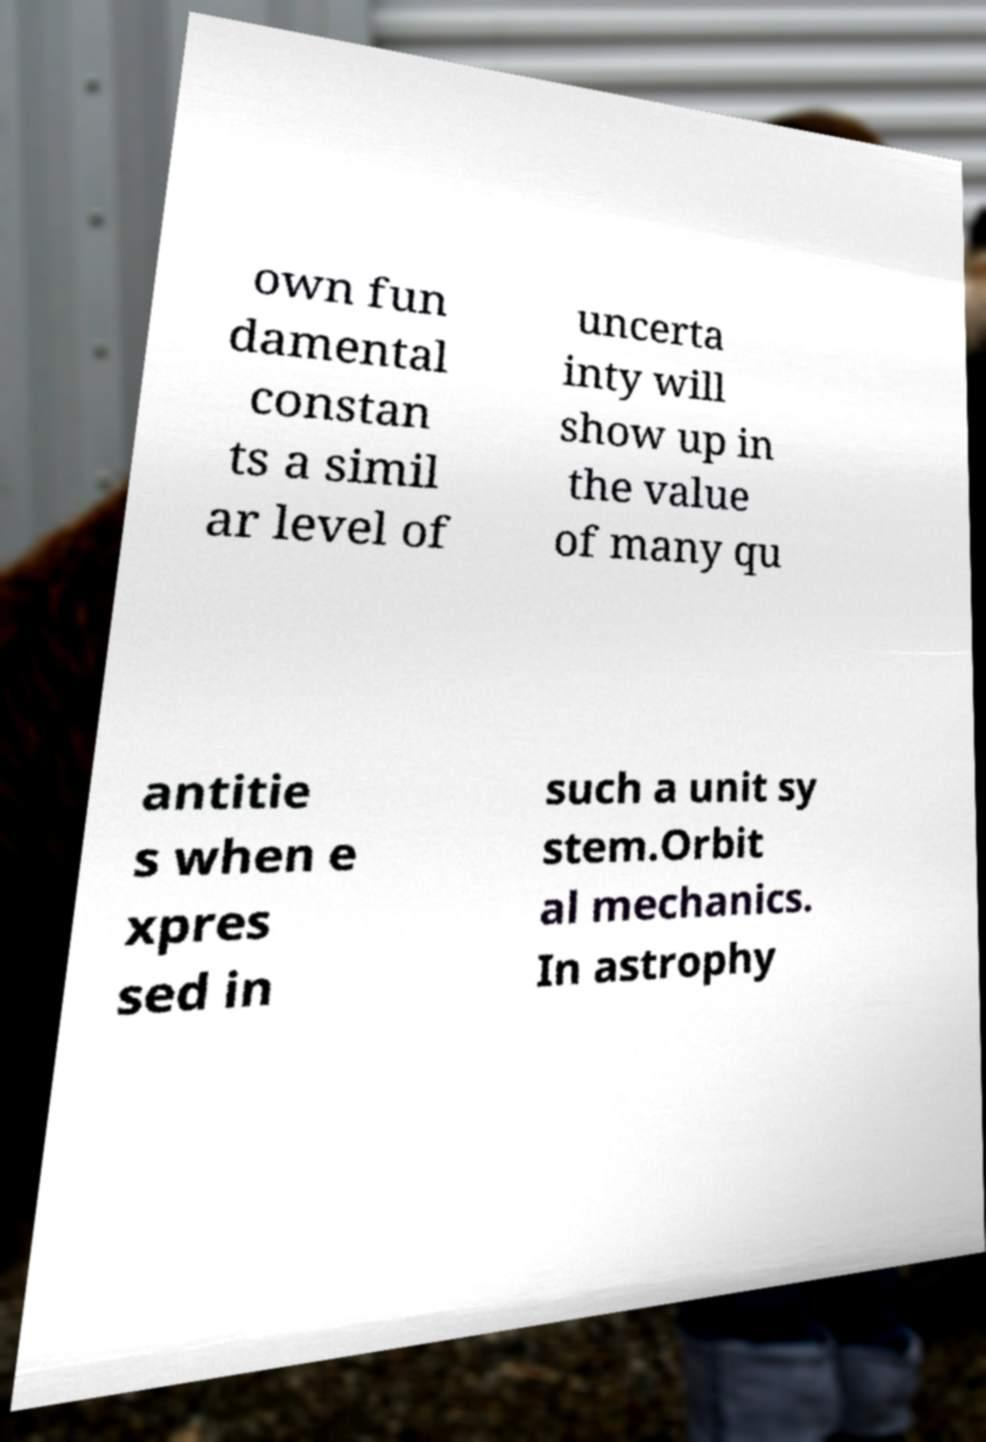Could you assist in decoding the text presented in this image and type it out clearly? own fun damental constan ts a simil ar level of uncerta inty will show up in the value of many qu antitie s when e xpres sed in such a unit sy stem.Orbit al mechanics. In astrophy 